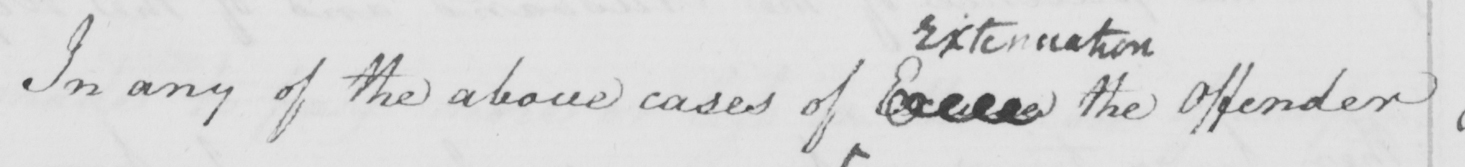Please transcribe the handwritten text in this image. In any of the above cases of Excuse the Offender 